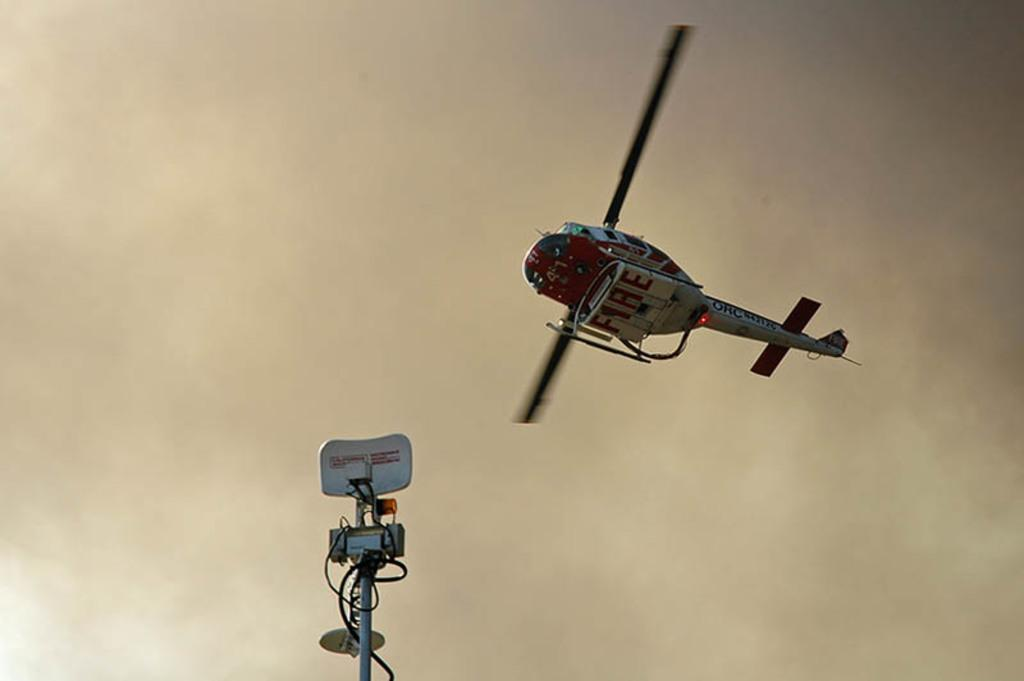Provide a one-sentence caption for the provided image. A red and white Helicopter with the word FIRE written on the bottom of it flying through some hazy smoke. 